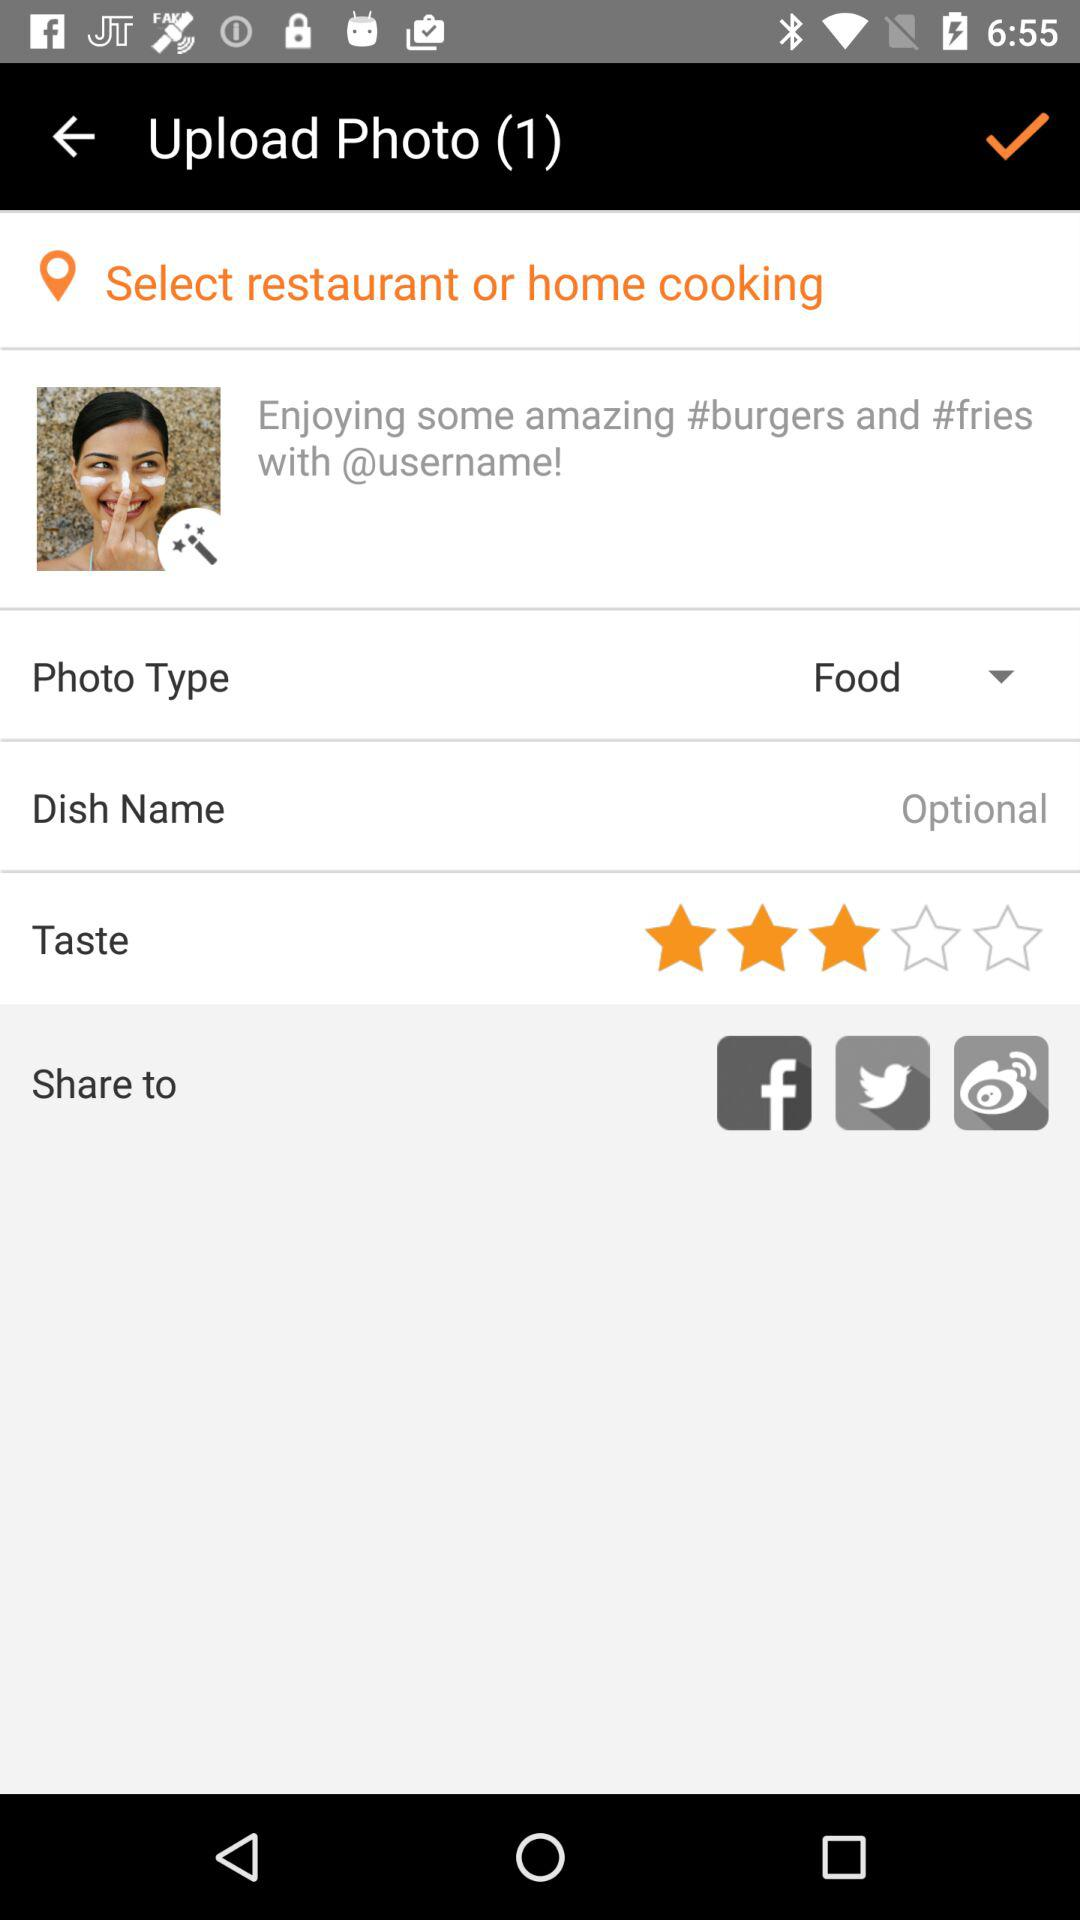What is the "Taste" rating? The "Taste" rating is 3 stars. 